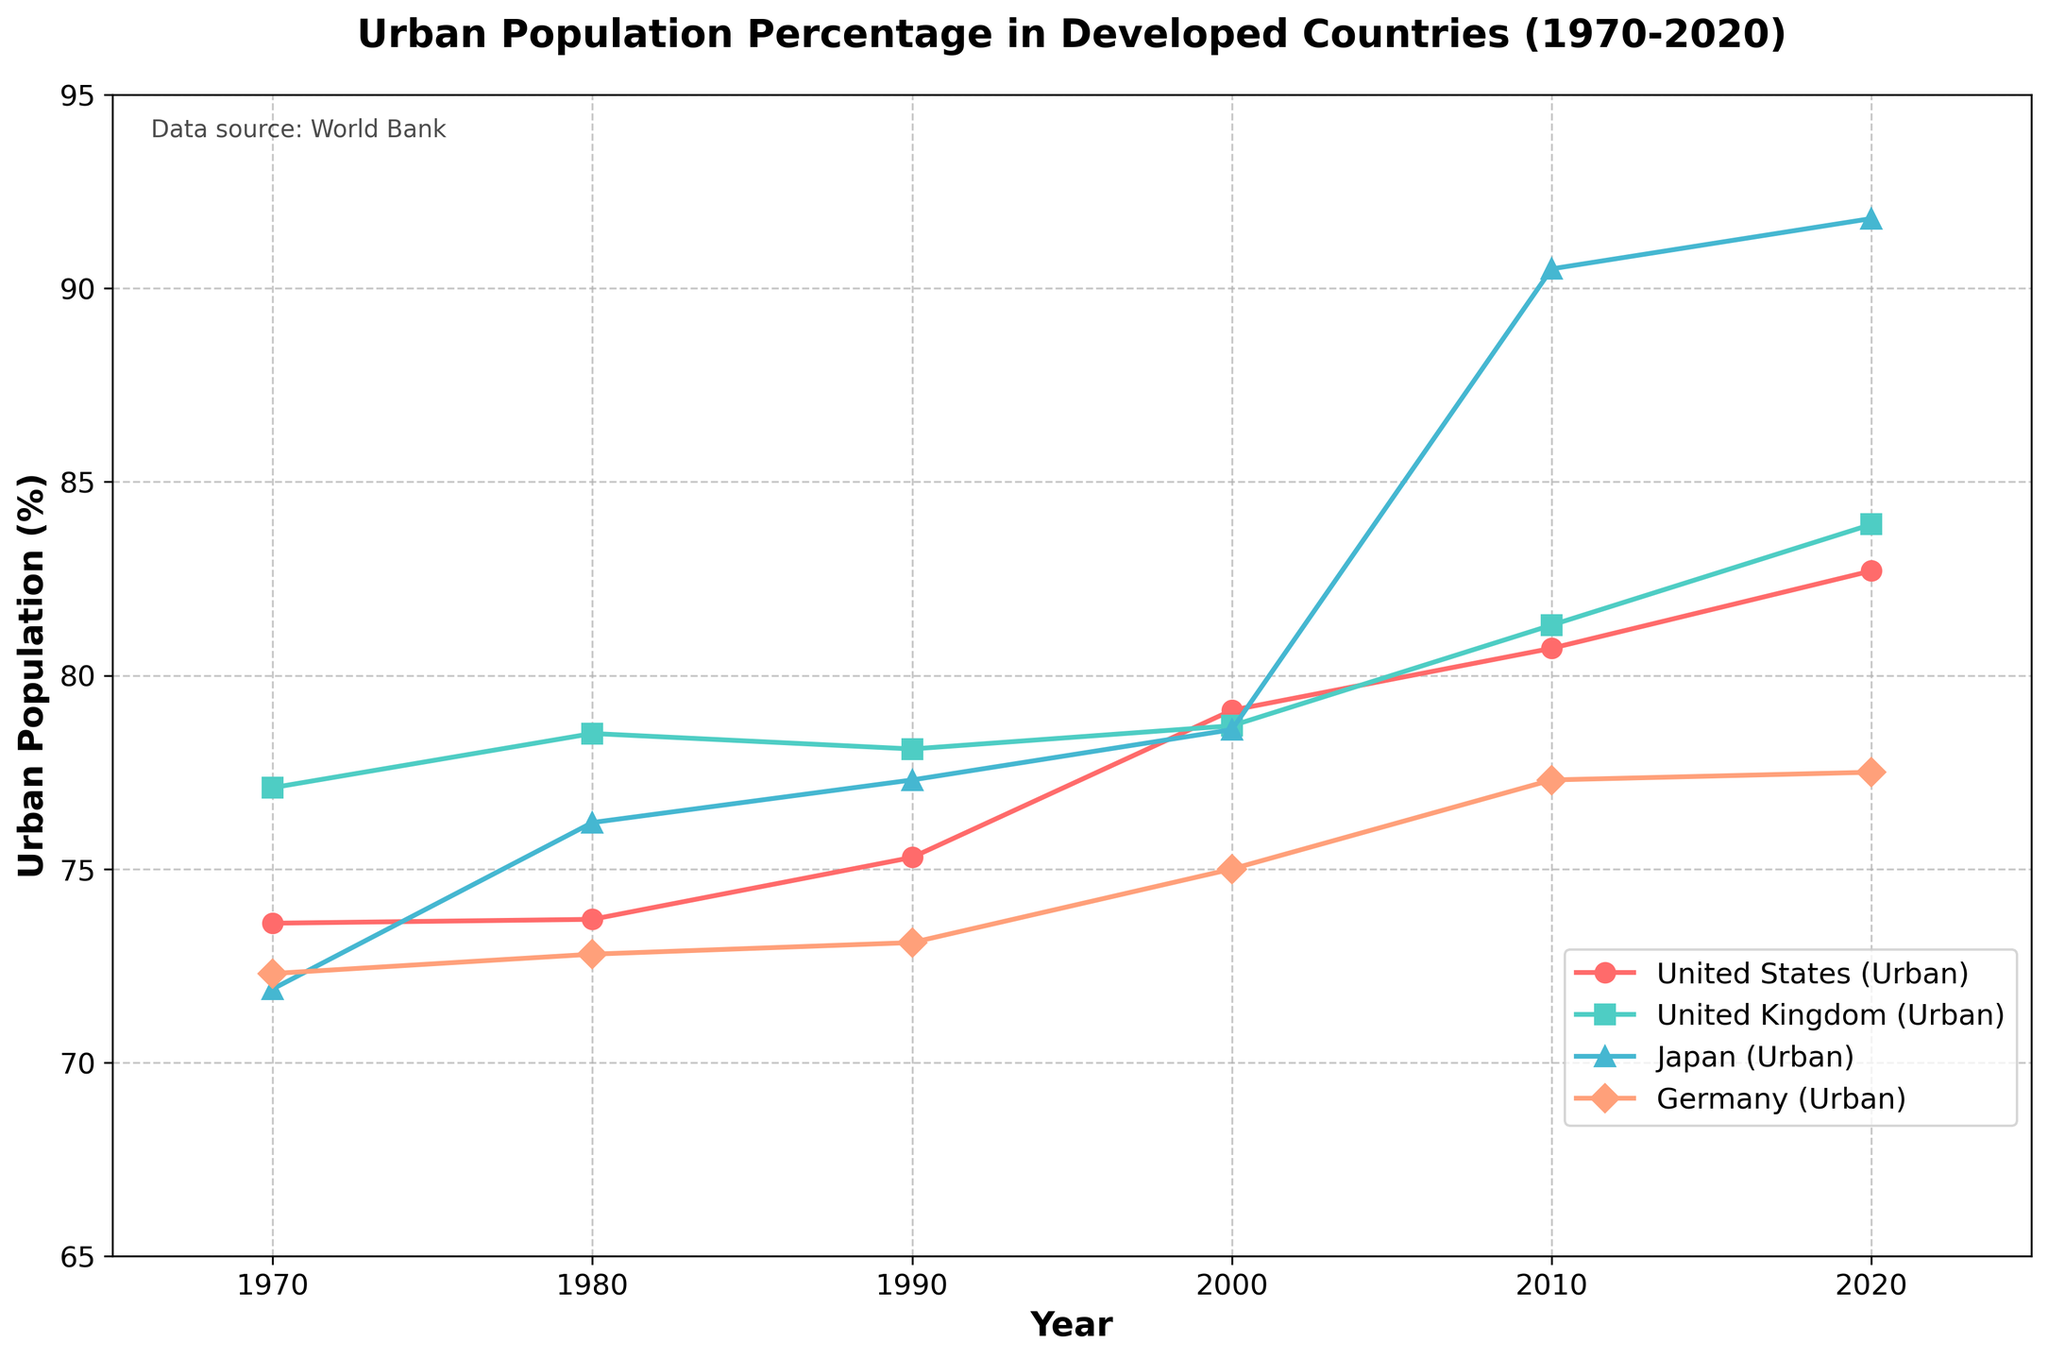What is the difference in urban population percentage between the United States and Japan in 2020? Look at the data points for urban population percentages of the United States and Japan in 2020. The US has 82.7% and Japan has 91.8%. Subtract 82.7 from 91.8 to find the difference.
Answer: 9.1% Which country had the highest urban population percentage in 1980? Check the data points for urban population percentages in 1980 for all the countries. Compare the values: the United States (73.7%), the United Kingdom (78.5%), Japan (76.2%), and Germany (72.8%). The highest percentage is the United Kingdom's 78.5%.
Answer: United Kingdom How did the urban population percentage of Germany change from 2000 to 2020? Look at the data points for Germany's urban population in 2000 and 2020. The values are 75.0% and 77.5%, respectively. Subtract 75.0 from 77.5 to find the change, which is an increase of 2.5%.
Answer: Increased by 2.5% Which country experienced the largest increase in urban population percentage from 2010 to 2020? Compare the urban population percentages of each country between 2010 and 2020. Subtract the values for each country and identify the largest difference. The differences are: United States (2%), United Kingdom (2.6%), Japan (1.3%), and Germany (0.2%). The largest increase is in the United Kingdom with 2.6%.
Answer: United Kingdom In which year did Japan's urban population percentage surpass 90%? Refer to the data points for Japan's urban population percentage and see when it first exceeds 90%. The values are: 71.9%, 76.2%, 77.3%, 78.6%, 90.5%, and 91.8%. It first surpasses 90% in 2010.
Answer: 2010 What is the average urban population percentage for the United Kingdom over the entire period? Add the urban population percentages of the United Kingdom for all years and divide by the number of years: (77.1 + 78.5 + 78.1 + 78.7 + 81.3 + 83.9) / 6. The sum is 477.6, and the average is 477.6 / 6.
Answer: 79.6% Which country's urban population percentage remained most stable throughout the period? Calculate the range (difference between the maximum and minimum values) of urban population percentages for each country: 
- United States: max 82.7, min 73.6, range 9.1
- United Kingdom: max 83.9, min 77.1, range 6.8
- Japan: max 91.8, min 71.9, range 19.9
- Germany: max 77.5, min 72.3, range 5.2. 
Germany has the smallest range of 5.2, making it the most stable.
Answer: Germany What is the visual difference in how the data for the United States is represented compared to Germany? Observe the plot for visual attributes like color and markers. The United States line is represented with red color and o markers, while Germany is shown with light salmon color and D markers.
Answer: Red color and o markers vs. light salmon color and D markers Comparing 1990 and 2000, how many countries had an increase in urban population percentage? Look at the data points for 1990 and 2000 and count which countries had an increase: 
- United States: 75.3 to 79.1 (increase)
- United Kingdom: 78.1 to 78.7 (increase)
- Japan: 77.3 to 78.6 (increase)
- Germany: 73.1 to 75.0 (increase). 
All four countries had an increase.
Answer: Four 